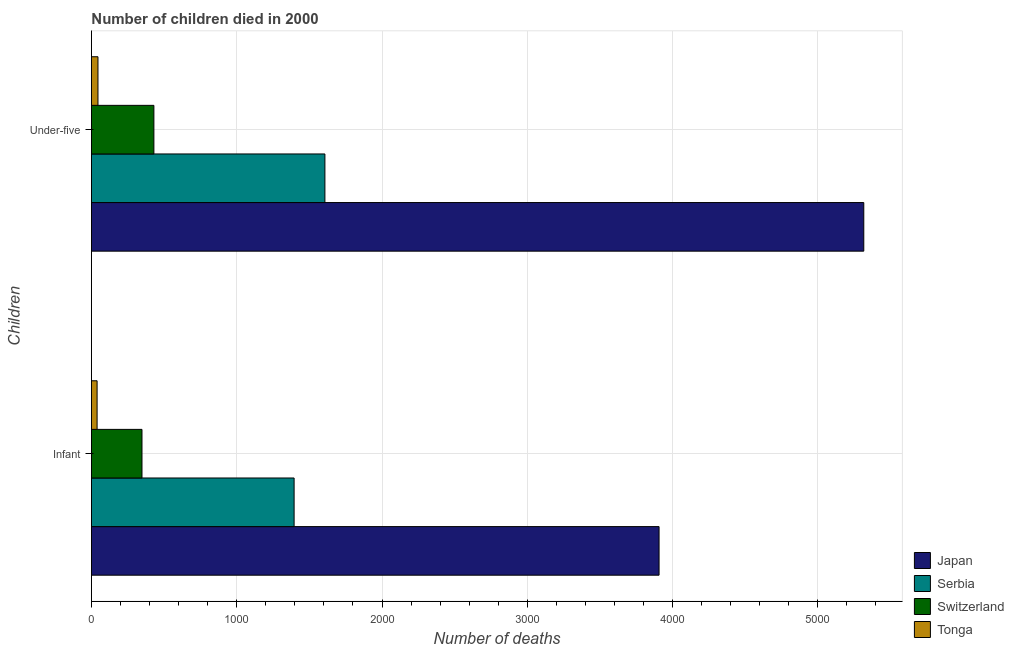How many different coloured bars are there?
Ensure brevity in your answer.  4. How many groups of bars are there?
Give a very brief answer. 2. Are the number of bars per tick equal to the number of legend labels?
Provide a short and direct response. Yes. Are the number of bars on each tick of the Y-axis equal?
Keep it short and to the point. Yes. What is the label of the 1st group of bars from the top?
Ensure brevity in your answer.  Under-five. What is the number of infant deaths in Japan?
Provide a short and direct response. 3907. Across all countries, what is the maximum number of infant deaths?
Your response must be concise. 3907. Across all countries, what is the minimum number of infant deaths?
Provide a short and direct response. 39. In which country was the number of under-five deaths maximum?
Keep it short and to the point. Japan. In which country was the number of under-five deaths minimum?
Offer a terse response. Tonga. What is the total number of infant deaths in the graph?
Your answer should be compact. 5689. What is the difference between the number of infant deaths in Serbia and that in Switzerland?
Your response must be concise. 1047. What is the difference between the number of under-five deaths in Switzerland and the number of infant deaths in Tonga?
Give a very brief answer. 391. What is the average number of under-five deaths per country?
Your answer should be very brief. 1849.5. What is the difference between the number of infant deaths and number of under-five deaths in Switzerland?
Provide a short and direct response. -82. What is the ratio of the number of infant deaths in Japan to that in Serbia?
Keep it short and to the point. 2.8. In how many countries, is the number of under-five deaths greater than the average number of under-five deaths taken over all countries?
Offer a very short reply. 1. What does the 3rd bar from the top in Infant represents?
Your answer should be compact. Serbia. What does the 2nd bar from the bottom in Infant represents?
Offer a very short reply. Serbia. Are all the bars in the graph horizontal?
Make the answer very short. Yes. What is the difference between two consecutive major ticks on the X-axis?
Provide a short and direct response. 1000. Are the values on the major ticks of X-axis written in scientific E-notation?
Make the answer very short. No. Does the graph contain grids?
Offer a very short reply. Yes. Where does the legend appear in the graph?
Provide a succinct answer. Bottom right. How many legend labels are there?
Ensure brevity in your answer.  4. How are the legend labels stacked?
Make the answer very short. Vertical. What is the title of the graph?
Your answer should be compact. Number of children died in 2000. Does "Bermuda" appear as one of the legend labels in the graph?
Keep it short and to the point. No. What is the label or title of the X-axis?
Keep it short and to the point. Number of deaths. What is the label or title of the Y-axis?
Provide a succinct answer. Children. What is the Number of deaths of Japan in Infant?
Give a very brief answer. 3907. What is the Number of deaths in Serbia in Infant?
Offer a terse response. 1395. What is the Number of deaths of Switzerland in Infant?
Offer a very short reply. 348. What is the Number of deaths of Japan in Under-five?
Offer a terse response. 5316. What is the Number of deaths in Serbia in Under-five?
Your response must be concise. 1607. What is the Number of deaths in Switzerland in Under-five?
Give a very brief answer. 430. Across all Children, what is the maximum Number of deaths of Japan?
Your answer should be very brief. 5316. Across all Children, what is the maximum Number of deaths in Serbia?
Your response must be concise. 1607. Across all Children, what is the maximum Number of deaths of Switzerland?
Make the answer very short. 430. Across all Children, what is the minimum Number of deaths of Japan?
Your answer should be very brief. 3907. Across all Children, what is the minimum Number of deaths of Serbia?
Provide a short and direct response. 1395. Across all Children, what is the minimum Number of deaths of Switzerland?
Make the answer very short. 348. Across all Children, what is the minimum Number of deaths of Tonga?
Give a very brief answer. 39. What is the total Number of deaths in Japan in the graph?
Make the answer very short. 9223. What is the total Number of deaths of Serbia in the graph?
Ensure brevity in your answer.  3002. What is the total Number of deaths in Switzerland in the graph?
Offer a very short reply. 778. What is the difference between the Number of deaths in Japan in Infant and that in Under-five?
Give a very brief answer. -1409. What is the difference between the Number of deaths in Serbia in Infant and that in Under-five?
Your answer should be very brief. -212. What is the difference between the Number of deaths in Switzerland in Infant and that in Under-five?
Your answer should be very brief. -82. What is the difference between the Number of deaths of Tonga in Infant and that in Under-five?
Keep it short and to the point. -6. What is the difference between the Number of deaths in Japan in Infant and the Number of deaths in Serbia in Under-five?
Keep it short and to the point. 2300. What is the difference between the Number of deaths of Japan in Infant and the Number of deaths of Switzerland in Under-five?
Your response must be concise. 3477. What is the difference between the Number of deaths in Japan in Infant and the Number of deaths in Tonga in Under-five?
Offer a terse response. 3862. What is the difference between the Number of deaths of Serbia in Infant and the Number of deaths of Switzerland in Under-five?
Offer a terse response. 965. What is the difference between the Number of deaths of Serbia in Infant and the Number of deaths of Tonga in Under-five?
Make the answer very short. 1350. What is the difference between the Number of deaths in Switzerland in Infant and the Number of deaths in Tonga in Under-five?
Provide a succinct answer. 303. What is the average Number of deaths of Japan per Children?
Provide a short and direct response. 4611.5. What is the average Number of deaths of Serbia per Children?
Your answer should be very brief. 1501. What is the average Number of deaths of Switzerland per Children?
Your answer should be very brief. 389. What is the average Number of deaths in Tonga per Children?
Your answer should be very brief. 42. What is the difference between the Number of deaths of Japan and Number of deaths of Serbia in Infant?
Your response must be concise. 2512. What is the difference between the Number of deaths of Japan and Number of deaths of Switzerland in Infant?
Make the answer very short. 3559. What is the difference between the Number of deaths in Japan and Number of deaths in Tonga in Infant?
Provide a succinct answer. 3868. What is the difference between the Number of deaths of Serbia and Number of deaths of Switzerland in Infant?
Make the answer very short. 1047. What is the difference between the Number of deaths of Serbia and Number of deaths of Tonga in Infant?
Provide a short and direct response. 1356. What is the difference between the Number of deaths in Switzerland and Number of deaths in Tonga in Infant?
Your answer should be compact. 309. What is the difference between the Number of deaths in Japan and Number of deaths in Serbia in Under-five?
Your response must be concise. 3709. What is the difference between the Number of deaths in Japan and Number of deaths in Switzerland in Under-five?
Your answer should be very brief. 4886. What is the difference between the Number of deaths of Japan and Number of deaths of Tonga in Under-five?
Ensure brevity in your answer.  5271. What is the difference between the Number of deaths in Serbia and Number of deaths in Switzerland in Under-five?
Offer a terse response. 1177. What is the difference between the Number of deaths in Serbia and Number of deaths in Tonga in Under-five?
Your answer should be compact. 1562. What is the difference between the Number of deaths in Switzerland and Number of deaths in Tonga in Under-five?
Provide a short and direct response. 385. What is the ratio of the Number of deaths in Japan in Infant to that in Under-five?
Make the answer very short. 0.73. What is the ratio of the Number of deaths in Serbia in Infant to that in Under-five?
Your response must be concise. 0.87. What is the ratio of the Number of deaths in Switzerland in Infant to that in Under-five?
Offer a terse response. 0.81. What is the ratio of the Number of deaths of Tonga in Infant to that in Under-five?
Give a very brief answer. 0.87. What is the difference between the highest and the second highest Number of deaths in Japan?
Your answer should be compact. 1409. What is the difference between the highest and the second highest Number of deaths in Serbia?
Provide a short and direct response. 212. What is the difference between the highest and the lowest Number of deaths of Japan?
Provide a succinct answer. 1409. What is the difference between the highest and the lowest Number of deaths of Serbia?
Ensure brevity in your answer.  212. What is the difference between the highest and the lowest Number of deaths in Tonga?
Your answer should be very brief. 6. 